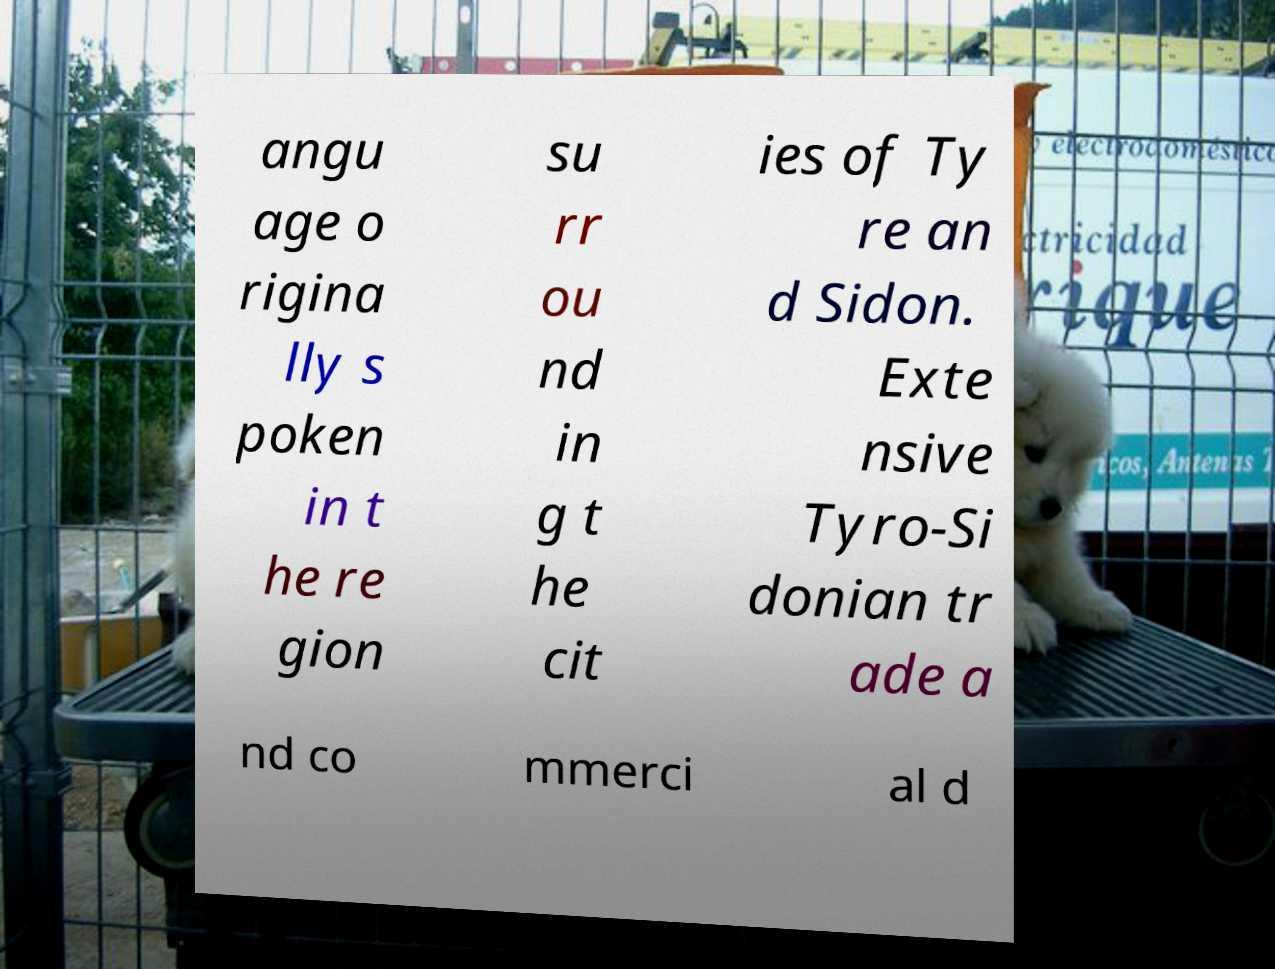For documentation purposes, I need the text within this image transcribed. Could you provide that? angu age o rigina lly s poken in t he re gion su rr ou nd in g t he cit ies of Ty re an d Sidon. Exte nsive Tyro-Si donian tr ade a nd co mmerci al d 